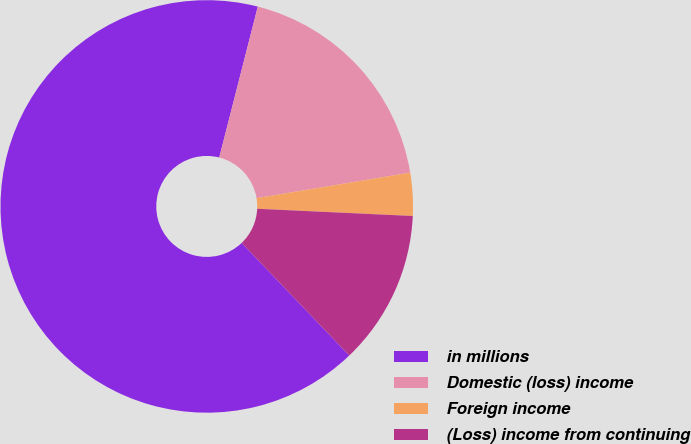Convert chart. <chart><loc_0><loc_0><loc_500><loc_500><pie_chart><fcel>in millions<fcel>Domestic (loss) income<fcel>Foreign income<fcel>(Loss) income from continuing<nl><fcel>66.13%<fcel>18.4%<fcel>3.36%<fcel>12.12%<nl></chart> 